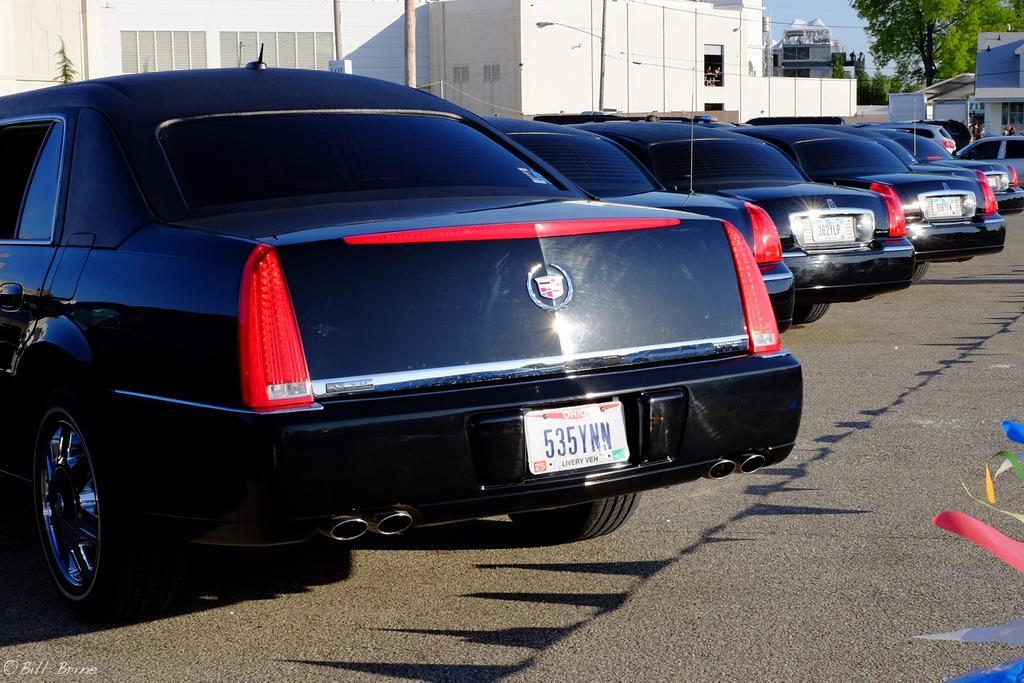How would you summarize this image in a sentence or two? In this image I can see number of cars, few trees, few buildings, few poles, the sky and over there I can see few people. I can also see something is written over here and here I can see few colourful things. 